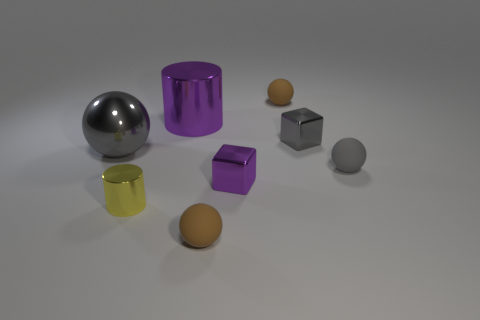What color is the tiny cylinder that is made of the same material as the large gray ball?
Provide a succinct answer. Yellow. Is the number of gray balls that are in front of the yellow metallic cylinder less than the number of blocks on the left side of the big gray ball?
Ensure brevity in your answer.  No. Does the large metal cylinder behind the tiny yellow metallic cylinder have the same color as the cylinder that is to the left of the large cylinder?
Your answer should be compact. No. Are there any big cyan cubes made of the same material as the tiny cylinder?
Give a very brief answer. No. There is a brown rubber object right of the purple shiny cube that is on the right side of the big shiny cylinder; how big is it?
Give a very brief answer. Small. Are there more purple metal cylinders than blue rubber blocks?
Ensure brevity in your answer.  Yes. Is the size of the gray sphere in front of the gray metallic ball the same as the big shiny ball?
Your answer should be compact. No. How many small metal things have the same color as the large sphere?
Make the answer very short. 1. Is the yellow shiny thing the same shape as the tiny purple thing?
Offer a terse response. No. Is there any other thing that is the same size as the yellow object?
Offer a very short reply. Yes. 